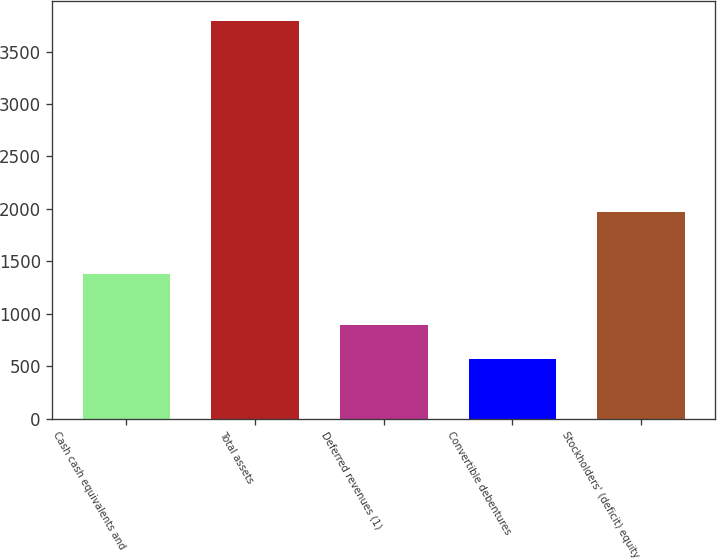Convert chart to OTSL. <chart><loc_0><loc_0><loc_500><loc_500><bar_chart><fcel>Cash cash equivalents and<fcel>Total assets<fcel>Deferred revenues (1)<fcel>Convertible debentures<fcel>Stockholders' (deficit) equity<nl><fcel>1377<fcel>3795<fcel>889.8<fcel>567<fcel>1969<nl></chart> 